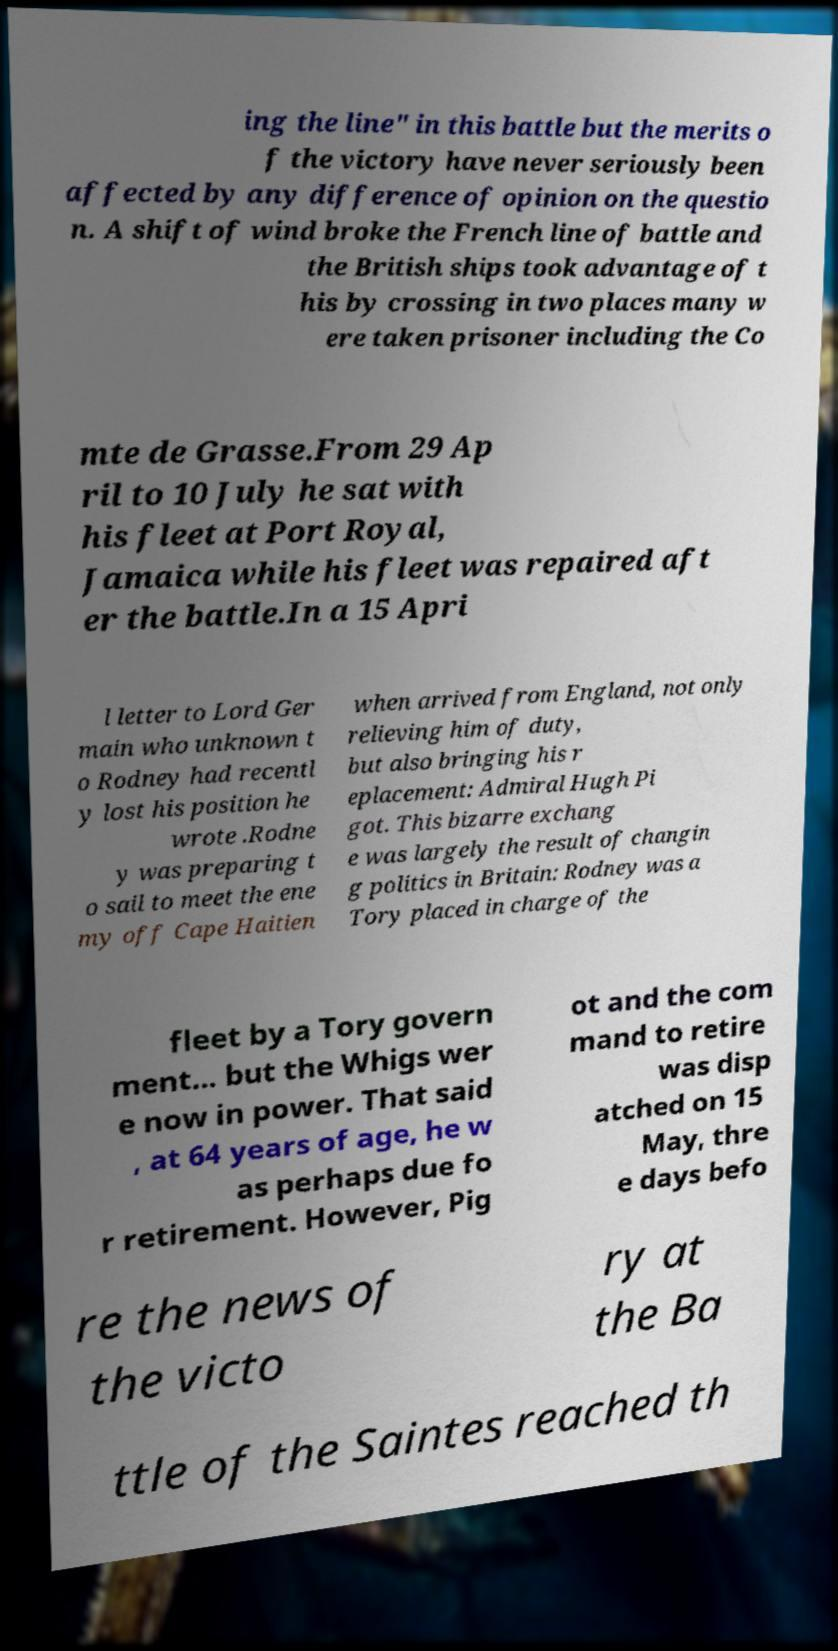There's text embedded in this image that I need extracted. Can you transcribe it verbatim? ing the line" in this battle but the merits o f the victory have never seriously been affected by any difference of opinion on the questio n. A shift of wind broke the French line of battle and the British ships took advantage of t his by crossing in two places many w ere taken prisoner including the Co mte de Grasse.From 29 Ap ril to 10 July he sat with his fleet at Port Royal, Jamaica while his fleet was repaired aft er the battle.In a 15 Apri l letter to Lord Ger main who unknown t o Rodney had recentl y lost his position he wrote .Rodne y was preparing t o sail to meet the ene my off Cape Haitien when arrived from England, not only relieving him of duty, but also bringing his r eplacement: Admiral Hugh Pi got. This bizarre exchang e was largely the result of changin g politics in Britain: Rodney was a Tory placed in charge of the fleet by a Tory govern ment... but the Whigs wer e now in power. That said , at 64 years of age, he w as perhaps due fo r retirement. However, Pig ot and the com mand to retire was disp atched on 15 May, thre e days befo re the news of the victo ry at the Ba ttle of the Saintes reached th 